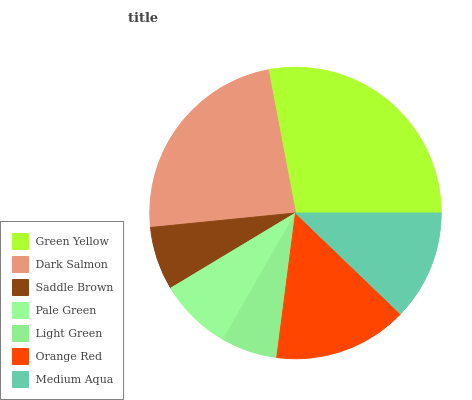Is Light Green the minimum?
Answer yes or no. Yes. Is Green Yellow the maximum?
Answer yes or no. Yes. Is Dark Salmon the minimum?
Answer yes or no. No. Is Dark Salmon the maximum?
Answer yes or no. No. Is Green Yellow greater than Dark Salmon?
Answer yes or no. Yes. Is Dark Salmon less than Green Yellow?
Answer yes or no. Yes. Is Dark Salmon greater than Green Yellow?
Answer yes or no. No. Is Green Yellow less than Dark Salmon?
Answer yes or no. No. Is Medium Aqua the high median?
Answer yes or no. Yes. Is Medium Aqua the low median?
Answer yes or no. Yes. Is Orange Red the high median?
Answer yes or no. No. Is Green Yellow the low median?
Answer yes or no. No. 